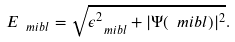Convert formula to latex. <formula><loc_0><loc_0><loc_500><loc_500>E _ { \ m i b l } = \sqrt { \epsilon _ { \ m i b l } ^ { 2 } + | \Psi ( { \ m i b l } ) | ^ { 2 } } .</formula> 